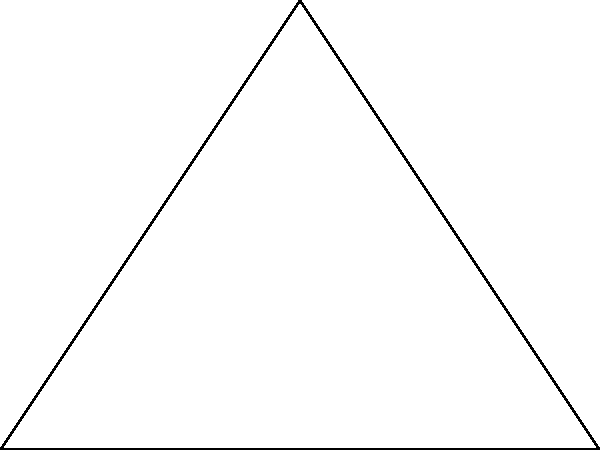In a government complex represented by triangle ABC, a security camera is to be placed at point O. If the camera has a circular surveillance range with radius r, what is the minimum value of r needed to ensure complete coverage of the complex? To find the minimum value of r that ensures complete coverage of the complex, we need to determine the distance from point O to the furthest vertex of the triangle. This distance will be the minimum required radius.

Step 1: Calculate the distances from O to each vertex.
1. Distance OA: $\sqrt{(2-0)^2 + (1-0)^2} = \sqrt{5}$
2. Distance OB: $\sqrt{(2-4)^2 + (1-0)^2} = \sqrt{5}$
3. Distance OC: $\sqrt{(2-2)^2 + (1-3)^2} = 2$

Step 2: Identify the maximum distance.
The maximum distance is $\sqrt{5}$, which occurs for both OA and OB.

Step 3: Conclude that the minimum value of r needed for complete coverage is $\sqrt{5}$.

This ensures that the circular surveillance range covers all vertices and, consequently, the entire triangle representing the government complex.
Answer: $\sqrt{5}$ 